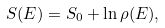<formula> <loc_0><loc_0><loc_500><loc_500>S ( E ) = S _ { 0 } + \ln \rho ( E ) ,</formula> 